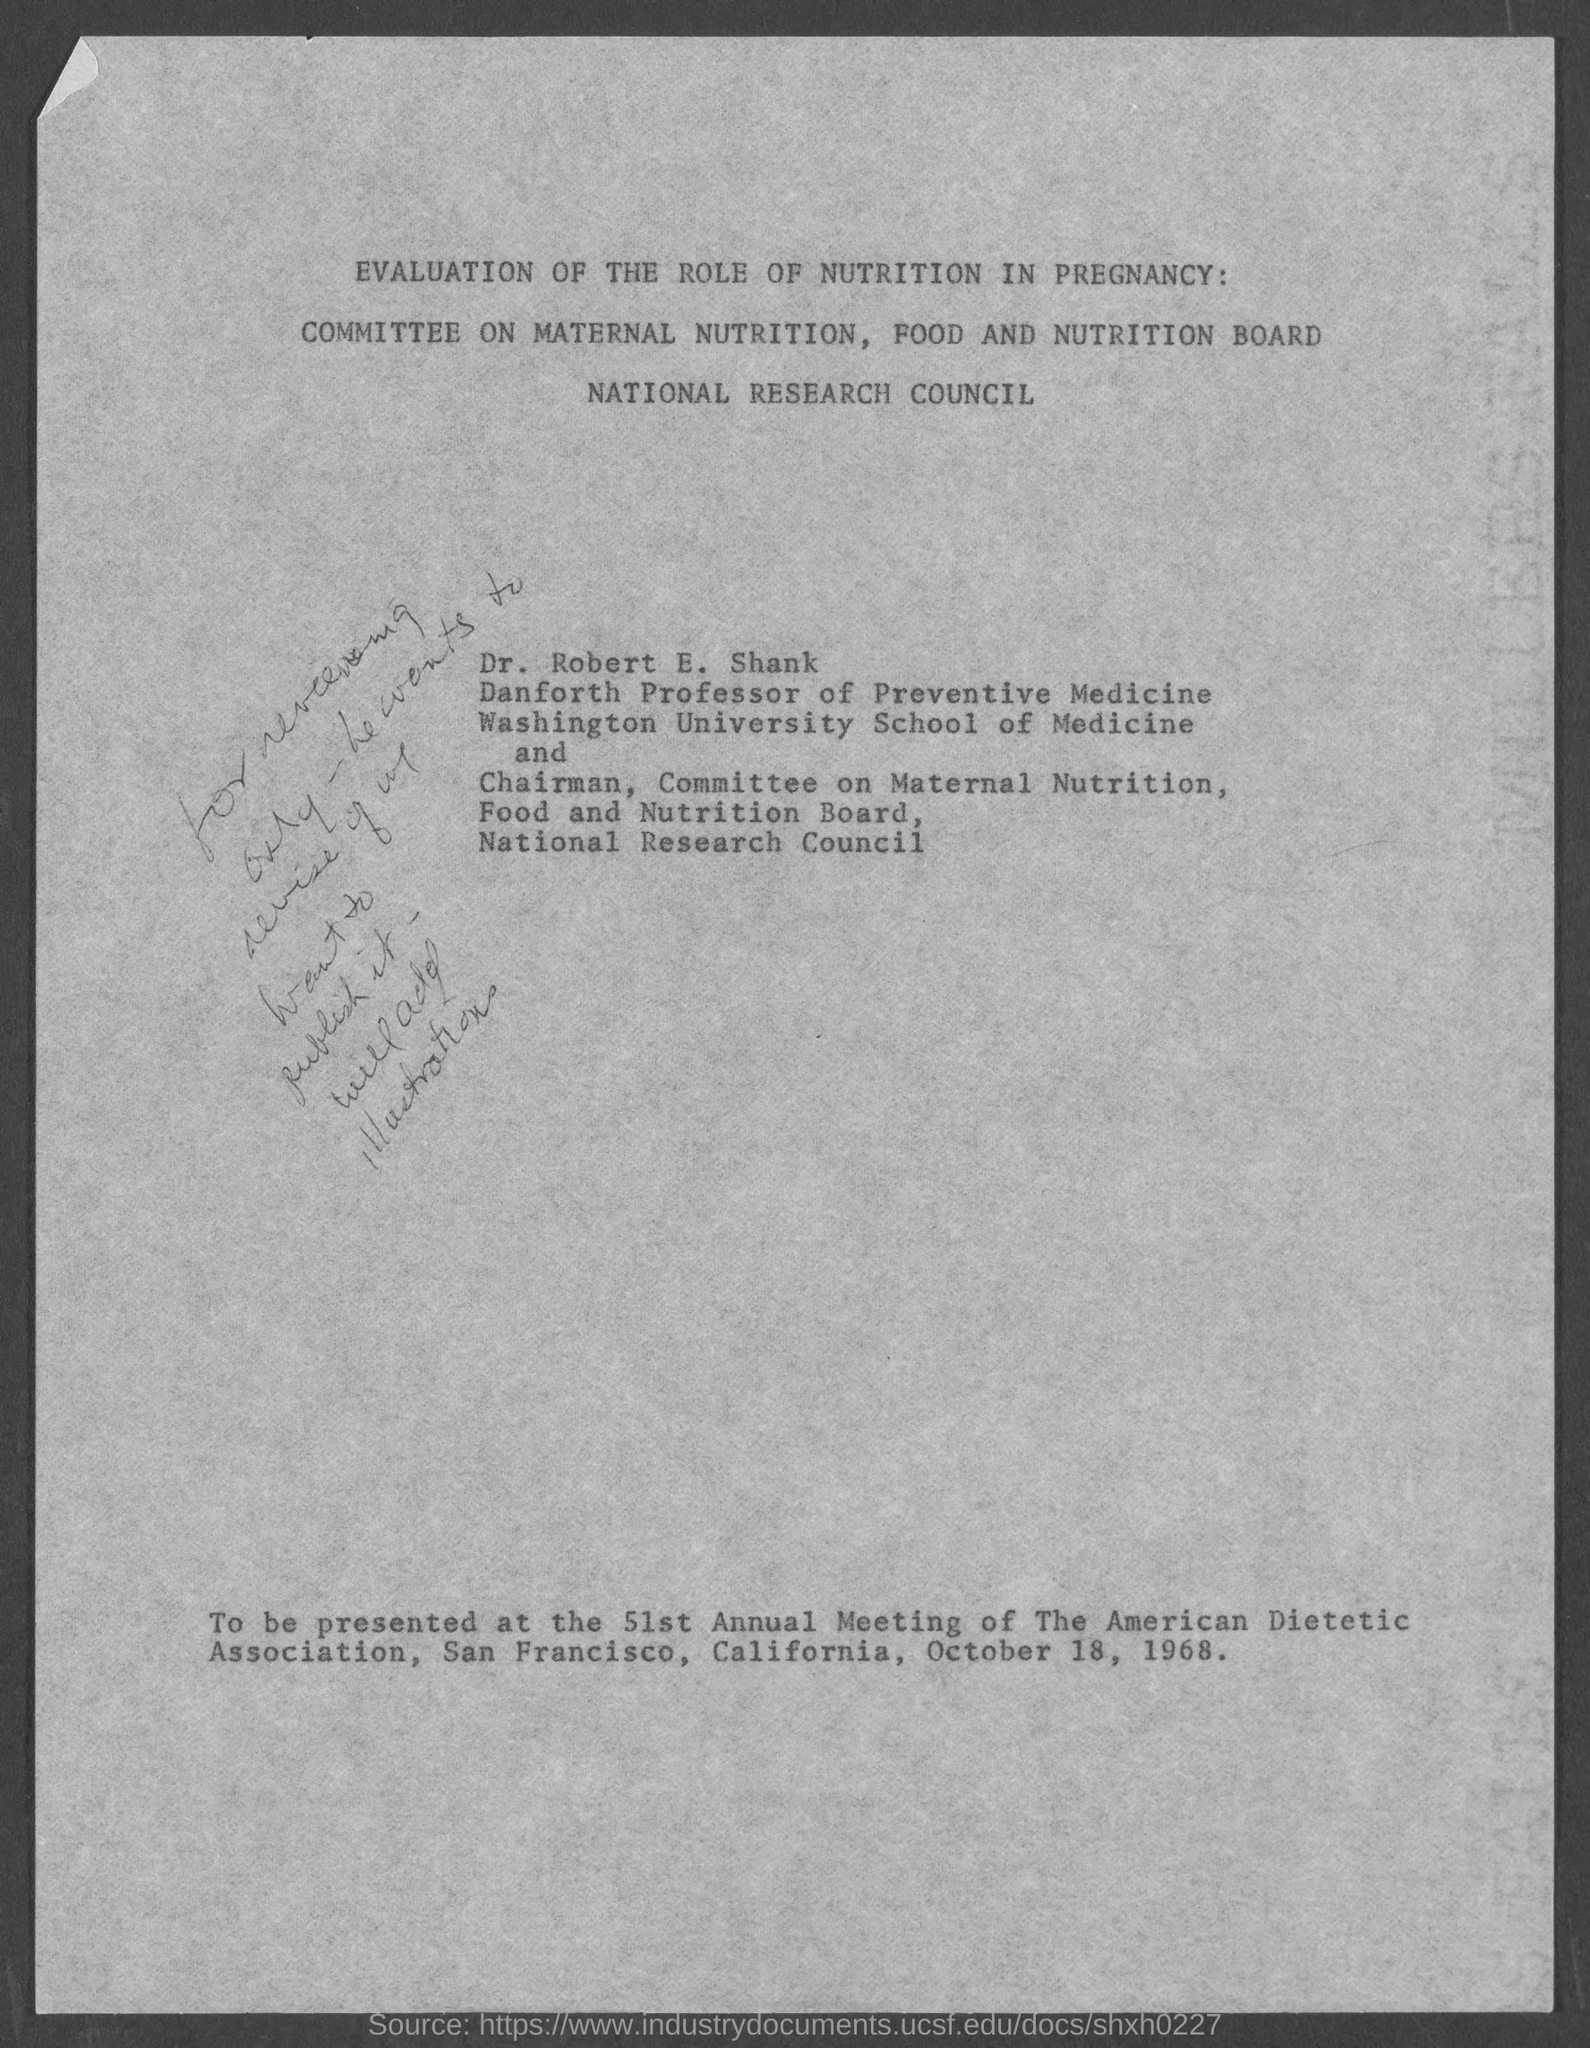When is the 51st annual meeting of the american dietetic association ?
Give a very brief answer. October 18, 1968. 